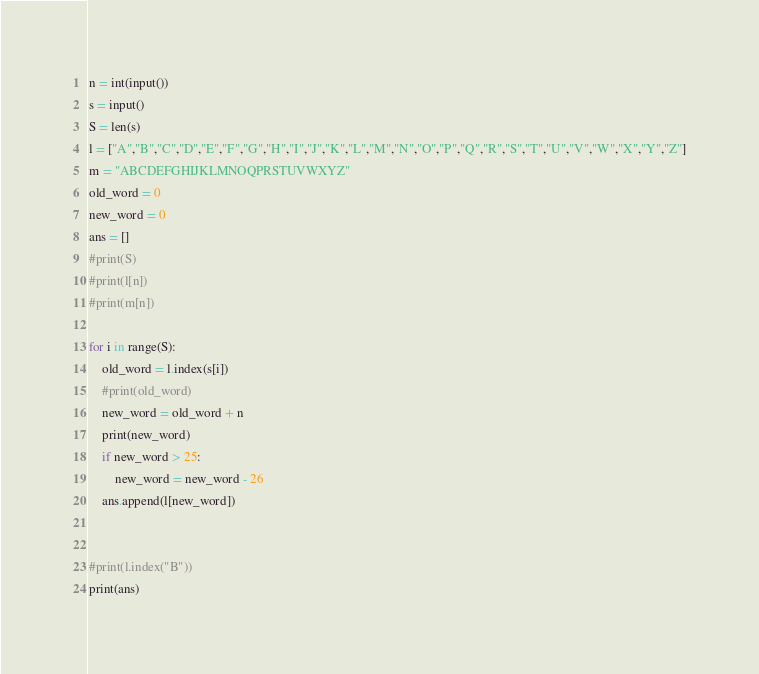<code> <loc_0><loc_0><loc_500><loc_500><_Python_>n = int(input())
s = input()
S = len(s)
l = ["A","B","C","D","E","F","G","H","I","J","K","L","M","N","O","P","Q","R","S","T","U","V","W","X","Y","Z"]
m = "ABCDEFGHIJKLMNOQPRSTUVWXYZ"
old_word = 0
new_word = 0
ans = []
#print(S)
#print(l[n])
#print(m[n])

for i in range(S):
    old_word = l.index(s[i])
    #print(old_word)
    new_word = old_word + n
    print(new_word)
    if new_word > 25:
        new_word = new_word - 26
    ans.append(l[new_word])


#print(l.index("B"))
print(ans)
</code> 